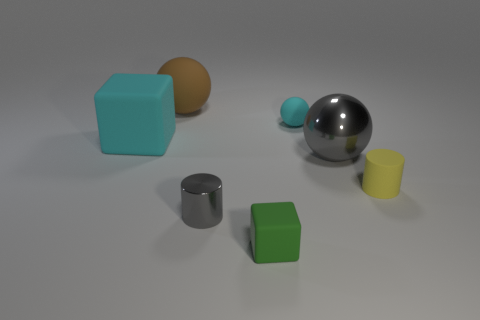What is the shape of the brown object that is the same material as the small yellow cylinder?
Your answer should be compact. Sphere. Are there fewer big gray objects that are in front of the small yellow rubber thing than small yellow things?
Give a very brief answer. Yes. The tiny cylinder in front of the small yellow cylinder is what color?
Make the answer very short. Gray. There is a large block that is the same color as the small ball; what material is it?
Your response must be concise. Rubber. Are there any small rubber things of the same shape as the small gray shiny object?
Offer a very short reply. Yes. What number of other big matte objects are the same shape as the green rubber thing?
Offer a very short reply. 1. Is the tiny metallic thing the same color as the shiny sphere?
Your answer should be very brief. Yes. Is the number of metallic things less than the number of small cyan metal spheres?
Make the answer very short. No. There is a cyan thing to the left of the tiny green cube; what material is it?
Your answer should be very brief. Rubber. There is a sphere that is the same size as the green thing; what is its material?
Offer a terse response. Rubber. 